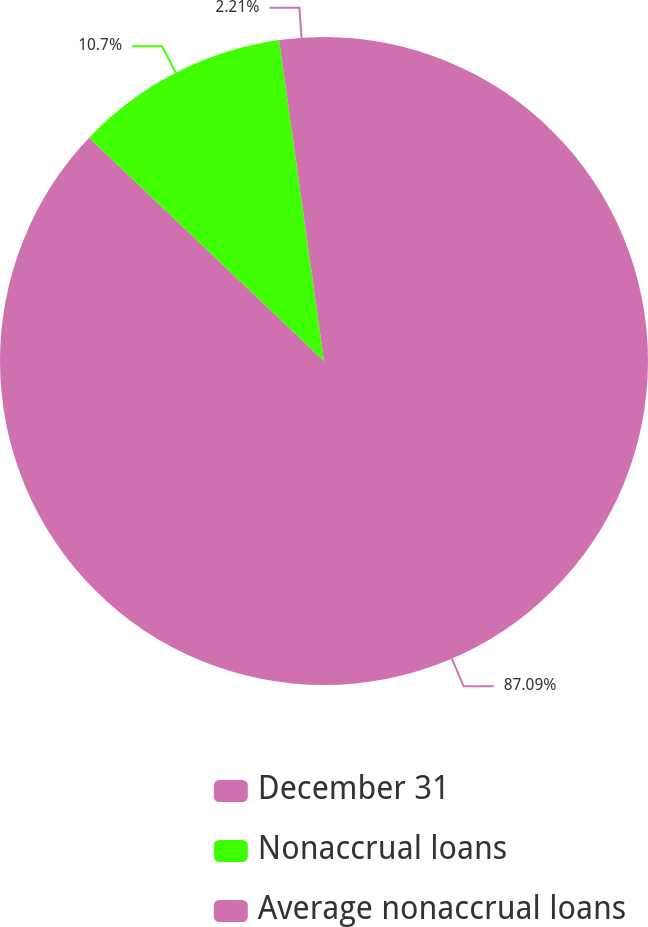<chart> <loc_0><loc_0><loc_500><loc_500><pie_chart><fcel>December 31<fcel>Nonaccrual loans<fcel>Average nonaccrual loans<nl><fcel>87.09%<fcel>10.7%<fcel>2.21%<nl></chart> 